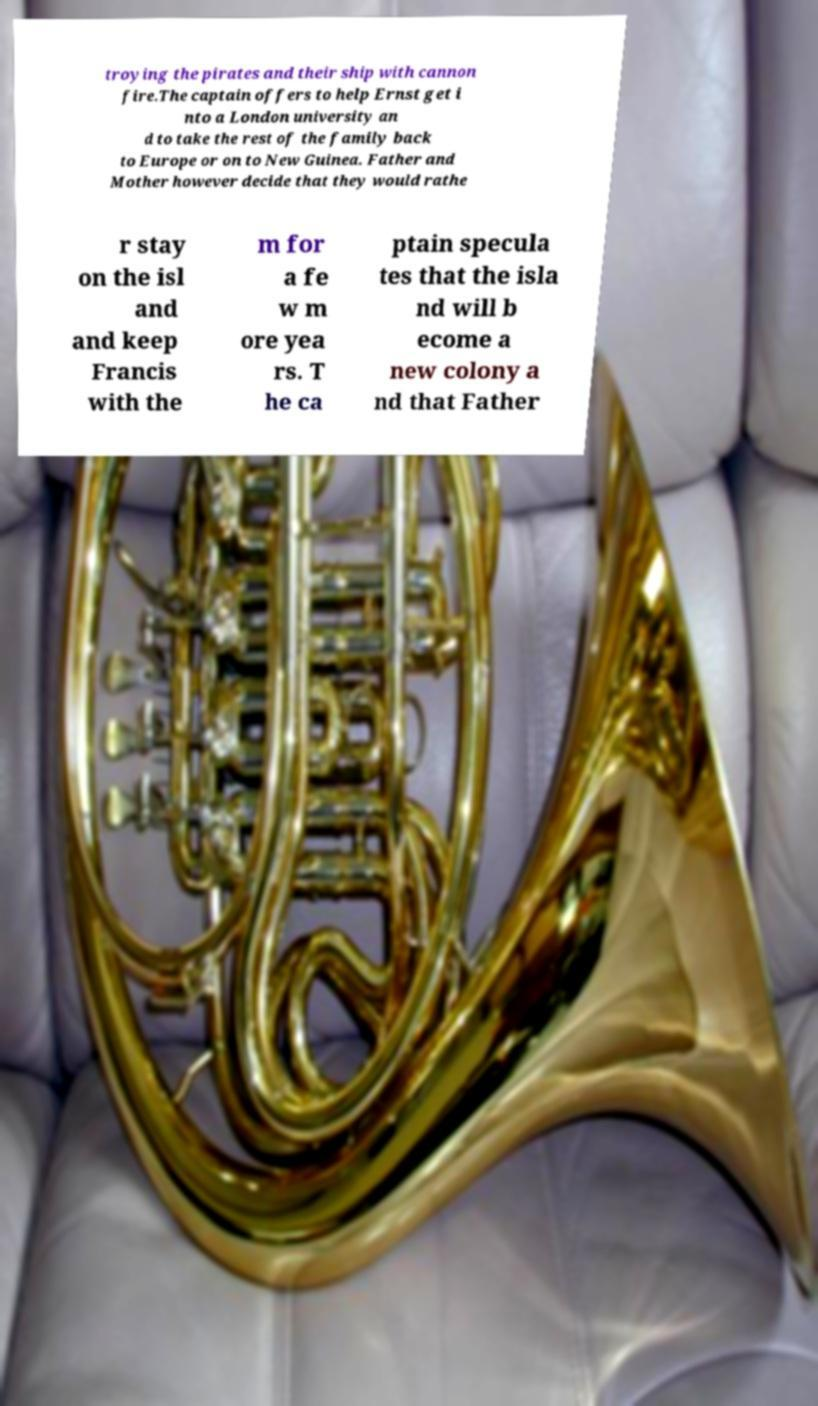Can you read and provide the text displayed in the image?This photo seems to have some interesting text. Can you extract and type it out for me? troying the pirates and their ship with cannon fire.The captain offers to help Ernst get i nto a London university an d to take the rest of the family back to Europe or on to New Guinea. Father and Mother however decide that they would rathe r stay on the isl and and keep Francis with the m for a fe w m ore yea rs. T he ca ptain specula tes that the isla nd will b ecome a new colony a nd that Father 